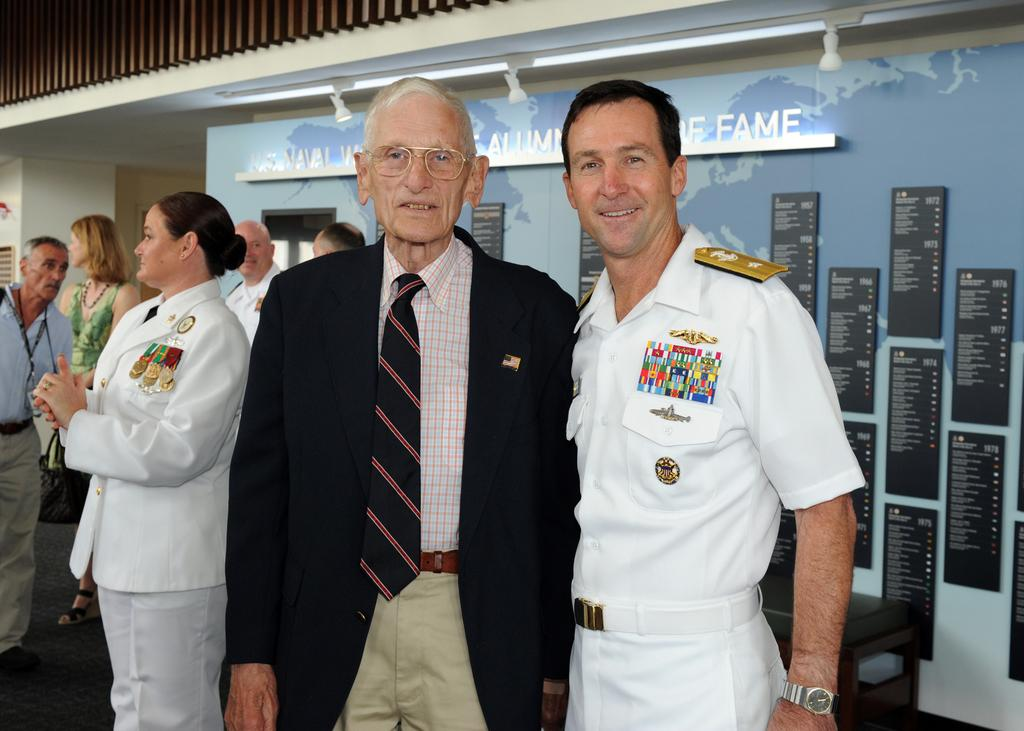<image>
Give a short and clear explanation of the subsequent image. naval officers along with others at a naval hall of fame 